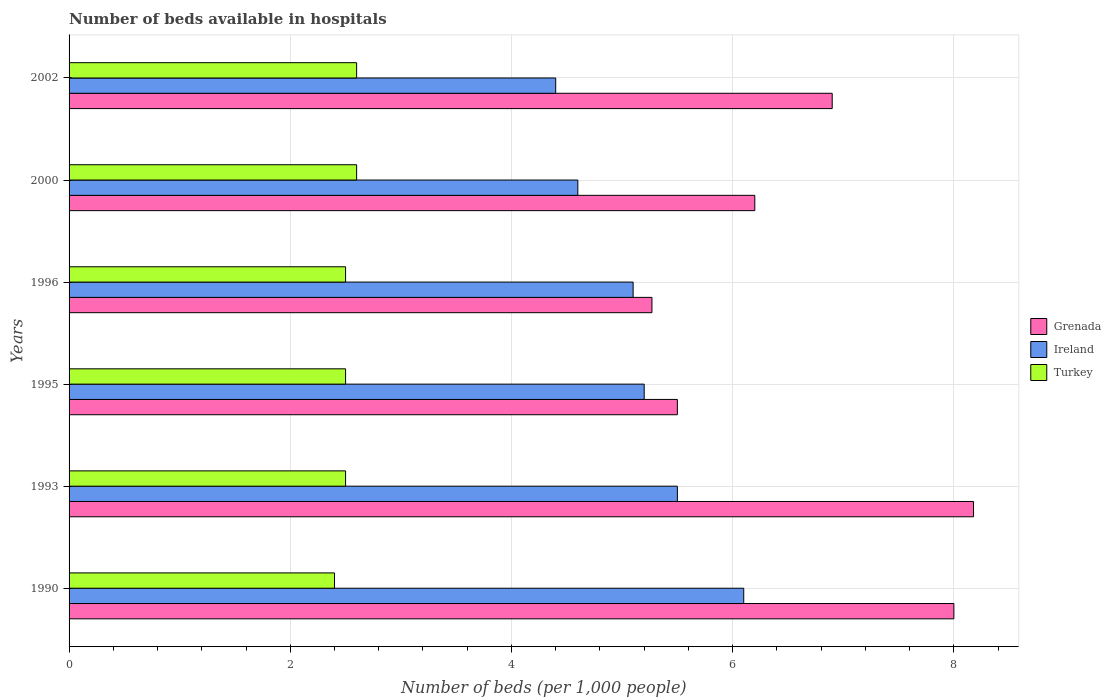How many different coloured bars are there?
Ensure brevity in your answer.  3. Are the number of bars on each tick of the Y-axis equal?
Offer a very short reply. Yes. How many bars are there on the 5th tick from the bottom?
Your answer should be very brief. 3. What is the number of beds in the hospiatls of in Turkey in 2002?
Your answer should be very brief. 2.6. Across all years, what is the maximum number of beds in the hospiatls of in Turkey?
Your response must be concise. 2.6. Across all years, what is the minimum number of beds in the hospiatls of in Ireland?
Provide a succinct answer. 4.4. In which year was the number of beds in the hospiatls of in Grenada maximum?
Provide a short and direct response. 1993. In which year was the number of beds in the hospiatls of in Ireland minimum?
Your answer should be very brief. 2002. What is the total number of beds in the hospiatls of in Grenada in the graph?
Offer a terse response. 40.05. What is the difference between the number of beds in the hospiatls of in Turkey in 1990 and that in 1996?
Your answer should be very brief. -0.1. What is the difference between the number of beds in the hospiatls of in Turkey in 1990 and the number of beds in the hospiatls of in Grenada in 2002?
Keep it short and to the point. -4.5. What is the average number of beds in the hospiatls of in Grenada per year?
Make the answer very short. 6.67. In the year 2002, what is the difference between the number of beds in the hospiatls of in Grenada and number of beds in the hospiatls of in Turkey?
Give a very brief answer. 4.3. In how many years, is the number of beds in the hospiatls of in Grenada greater than 7.6 ?
Provide a short and direct response. 2. What is the ratio of the number of beds in the hospiatls of in Ireland in 1993 to that in 2000?
Make the answer very short. 1.2. Is the number of beds in the hospiatls of in Turkey in 1996 less than that in 2000?
Offer a terse response. Yes. What is the difference between the highest and the second highest number of beds in the hospiatls of in Grenada?
Give a very brief answer. 0.18. What is the difference between the highest and the lowest number of beds in the hospiatls of in Grenada?
Offer a very short reply. 2.91. In how many years, is the number of beds in the hospiatls of in Turkey greater than the average number of beds in the hospiatls of in Turkey taken over all years?
Your answer should be very brief. 2. Is the sum of the number of beds in the hospiatls of in Grenada in 1990 and 1996 greater than the maximum number of beds in the hospiatls of in Turkey across all years?
Provide a succinct answer. Yes. What does the 1st bar from the bottom in 1990 represents?
Offer a very short reply. Grenada. How many bars are there?
Keep it short and to the point. 18. Are all the bars in the graph horizontal?
Make the answer very short. Yes. How many years are there in the graph?
Your answer should be very brief. 6. What is the difference between two consecutive major ticks on the X-axis?
Offer a terse response. 2. Does the graph contain any zero values?
Keep it short and to the point. No. Does the graph contain grids?
Your response must be concise. Yes. Where does the legend appear in the graph?
Keep it short and to the point. Center right. How many legend labels are there?
Make the answer very short. 3. What is the title of the graph?
Provide a succinct answer. Number of beds available in hospitals. Does "Congo (Democratic)" appear as one of the legend labels in the graph?
Give a very brief answer. No. What is the label or title of the X-axis?
Keep it short and to the point. Number of beds (per 1,0 people). What is the Number of beds (per 1,000 people) of Ireland in 1990?
Offer a terse response. 6.1. What is the Number of beds (per 1,000 people) in Turkey in 1990?
Offer a very short reply. 2.4. What is the Number of beds (per 1,000 people) in Grenada in 1993?
Your answer should be compact. 8.18. What is the Number of beds (per 1,000 people) in Ireland in 1993?
Your response must be concise. 5.5. What is the Number of beds (per 1,000 people) in Grenada in 1995?
Your answer should be very brief. 5.5. What is the Number of beds (per 1,000 people) of Ireland in 1995?
Give a very brief answer. 5.2. What is the Number of beds (per 1,000 people) in Turkey in 1995?
Provide a succinct answer. 2.5. What is the Number of beds (per 1,000 people) of Grenada in 1996?
Give a very brief answer. 5.27. What is the Number of beds (per 1,000 people) in Ireland in 1996?
Your answer should be compact. 5.1. What is the Number of beds (per 1,000 people) of Grenada in 2000?
Ensure brevity in your answer.  6.2. What is the Number of beds (per 1,000 people) of Ireland in 2000?
Make the answer very short. 4.6. What is the Number of beds (per 1,000 people) of Turkey in 2000?
Your response must be concise. 2.6. What is the Number of beds (per 1,000 people) of Grenada in 2002?
Give a very brief answer. 6.9. What is the Number of beds (per 1,000 people) of Ireland in 2002?
Keep it short and to the point. 4.4. What is the Number of beds (per 1,000 people) of Turkey in 2002?
Offer a terse response. 2.6. Across all years, what is the maximum Number of beds (per 1,000 people) in Grenada?
Make the answer very short. 8.18. Across all years, what is the maximum Number of beds (per 1,000 people) of Ireland?
Keep it short and to the point. 6.1. Across all years, what is the maximum Number of beds (per 1,000 people) in Turkey?
Ensure brevity in your answer.  2.6. Across all years, what is the minimum Number of beds (per 1,000 people) of Grenada?
Offer a very short reply. 5.27. Across all years, what is the minimum Number of beds (per 1,000 people) in Ireland?
Provide a succinct answer. 4.4. Across all years, what is the minimum Number of beds (per 1,000 people) of Turkey?
Offer a very short reply. 2.4. What is the total Number of beds (per 1,000 people) of Grenada in the graph?
Your response must be concise. 40.05. What is the total Number of beds (per 1,000 people) of Ireland in the graph?
Your answer should be compact. 30.9. What is the total Number of beds (per 1,000 people) in Turkey in the graph?
Your answer should be very brief. 15.1. What is the difference between the Number of beds (per 1,000 people) in Grenada in 1990 and that in 1993?
Ensure brevity in your answer.  -0.18. What is the difference between the Number of beds (per 1,000 people) in Ireland in 1990 and that in 1993?
Offer a terse response. 0.6. What is the difference between the Number of beds (per 1,000 people) in Turkey in 1990 and that in 1993?
Offer a very short reply. -0.1. What is the difference between the Number of beds (per 1,000 people) of Grenada in 1990 and that in 1995?
Offer a very short reply. 2.5. What is the difference between the Number of beds (per 1,000 people) of Grenada in 1990 and that in 1996?
Your answer should be very brief. 2.73. What is the difference between the Number of beds (per 1,000 people) of Ireland in 1990 and that in 1996?
Make the answer very short. 1. What is the difference between the Number of beds (per 1,000 people) of Turkey in 1990 and that in 1996?
Your response must be concise. -0.1. What is the difference between the Number of beds (per 1,000 people) of Grenada in 1990 and that in 2000?
Keep it short and to the point. 1.8. What is the difference between the Number of beds (per 1,000 people) in Ireland in 1990 and that in 2000?
Make the answer very short. 1.5. What is the difference between the Number of beds (per 1,000 people) in Grenada in 1993 and that in 1995?
Offer a very short reply. 2.68. What is the difference between the Number of beds (per 1,000 people) in Turkey in 1993 and that in 1995?
Your response must be concise. 0. What is the difference between the Number of beds (per 1,000 people) in Grenada in 1993 and that in 1996?
Offer a very short reply. 2.91. What is the difference between the Number of beds (per 1,000 people) of Turkey in 1993 and that in 1996?
Offer a very short reply. 0. What is the difference between the Number of beds (per 1,000 people) of Grenada in 1993 and that in 2000?
Your answer should be compact. 1.98. What is the difference between the Number of beds (per 1,000 people) of Ireland in 1993 and that in 2000?
Make the answer very short. 0.9. What is the difference between the Number of beds (per 1,000 people) in Turkey in 1993 and that in 2000?
Your response must be concise. -0.1. What is the difference between the Number of beds (per 1,000 people) in Grenada in 1993 and that in 2002?
Offer a terse response. 1.28. What is the difference between the Number of beds (per 1,000 people) of Turkey in 1993 and that in 2002?
Your answer should be very brief. -0.1. What is the difference between the Number of beds (per 1,000 people) of Grenada in 1995 and that in 1996?
Keep it short and to the point. 0.23. What is the difference between the Number of beds (per 1,000 people) in Ireland in 1995 and that in 1996?
Make the answer very short. 0.1. What is the difference between the Number of beds (per 1,000 people) in Turkey in 1995 and that in 2000?
Your answer should be compact. -0.1. What is the difference between the Number of beds (per 1,000 people) of Grenada in 1995 and that in 2002?
Your response must be concise. -1.4. What is the difference between the Number of beds (per 1,000 people) of Ireland in 1995 and that in 2002?
Keep it short and to the point. 0.8. What is the difference between the Number of beds (per 1,000 people) in Grenada in 1996 and that in 2000?
Your answer should be very brief. -0.93. What is the difference between the Number of beds (per 1,000 people) in Turkey in 1996 and that in 2000?
Offer a terse response. -0.1. What is the difference between the Number of beds (per 1,000 people) in Grenada in 1996 and that in 2002?
Offer a very short reply. -1.63. What is the difference between the Number of beds (per 1,000 people) of Turkey in 1996 and that in 2002?
Your answer should be compact. -0.1. What is the difference between the Number of beds (per 1,000 people) in Grenada in 2000 and that in 2002?
Offer a very short reply. -0.7. What is the difference between the Number of beds (per 1,000 people) of Grenada in 1990 and the Number of beds (per 1,000 people) of Ireland in 1993?
Provide a succinct answer. 2.5. What is the difference between the Number of beds (per 1,000 people) in Grenada in 1990 and the Number of beds (per 1,000 people) in Turkey in 1993?
Give a very brief answer. 5.5. What is the difference between the Number of beds (per 1,000 people) in Grenada in 1990 and the Number of beds (per 1,000 people) in Turkey in 1995?
Provide a succinct answer. 5.5. What is the difference between the Number of beds (per 1,000 people) in Grenada in 1990 and the Number of beds (per 1,000 people) in Turkey in 2000?
Your response must be concise. 5.4. What is the difference between the Number of beds (per 1,000 people) in Grenada in 1990 and the Number of beds (per 1,000 people) in Ireland in 2002?
Your answer should be very brief. 3.6. What is the difference between the Number of beds (per 1,000 people) of Grenada in 1993 and the Number of beds (per 1,000 people) of Ireland in 1995?
Keep it short and to the point. 2.98. What is the difference between the Number of beds (per 1,000 people) of Grenada in 1993 and the Number of beds (per 1,000 people) of Turkey in 1995?
Provide a succinct answer. 5.68. What is the difference between the Number of beds (per 1,000 people) in Ireland in 1993 and the Number of beds (per 1,000 people) in Turkey in 1995?
Make the answer very short. 3. What is the difference between the Number of beds (per 1,000 people) in Grenada in 1993 and the Number of beds (per 1,000 people) in Ireland in 1996?
Offer a terse response. 3.08. What is the difference between the Number of beds (per 1,000 people) in Grenada in 1993 and the Number of beds (per 1,000 people) in Turkey in 1996?
Make the answer very short. 5.68. What is the difference between the Number of beds (per 1,000 people) of Grenada in 1993 and the Number of beds (per 1,000 people) of Ireland in 2000?
Keep it short and to the point. 3.58. What is the difference between the Number of beds (per 1,000 people) of Grenada in 1993 and the Number of beds (per 1,000 people) of Turkey in 2000?
Your answer should be compact. 5.58. What is the difference between the Number of beds (per 1,000 people) of Grenada in 1993 and the Number of beds (per 1,000 people) of Ireland in 2002?
Your answer should be very brief. 3.78. What is the difference between the Number of beds (per 1,000 people) in Grenada in 1993 and the Number of beds (per 1,000 people) in Turkey in 2002?
Offer a terse response. 5.58. What is the difference between the Number of beds (per 1,000 people) of Grenada in 1995 and the Number of beds (per 1,000 people) of Ireland in 1996?
Your answer should be compact. 0.4. What is the difference between the Number of beds (per 1,000 people) in Ireland in 1995 and the Number of beds (per 1,000 people) in Turkey in 1996?
Offer a very short reply. 2.7. What is the difference between the Number of beds (per 1,000 people) in Grenada in 1995 and the Number of beds (per 1,000 people) in Turkey in 2002?
Give a very brief answer. 2.9. What is the difference between the Number of beds (per 1,000 people) in Ireland in 1995 and the Number of beds (per 1,000 people) in Turkey in 2002?
Offer a terse response. 2.6. What is the difference between the Number of beds (per 1,000 people) of Grenada in 1996 and the Number of beds (per 1,000 people) of Ireland in 2000?
Give a very brief answer. 0.67. What is the difference between the Number of beds (per 1,000 people) of Grenada in 1996 and the Number of beds (per 1,000 people) of Turkey in 2000?
Offer a very short reply. 2.67. What is the difference between the Number of beds (per 1,000 people) in Ireland in 1996 and the Number of beds (per 1,000 people) in Turkey in 2000?
Provide a short and direct response. 2.5. What is the difference between the Number of beds (per 1,000 people) in Grenada in 1996 and the Number of beds (per 1,000 people) in Ireland in 2002?
Give a very brief answer. 0.87. What is the difference between the Number of beds (per 1,000 people) in Grenada in 1996 and the Number of beds (per 1,000 people) in Turkey in 2002?
Offer a terse response. 2.67. What is the difference between the Number of beds (per 1,000 people) of Ireland in 1996 and the Number of beds (per 1,000 people) of Turkey in 2002?
Make the answer very short. 2.5. What is the difference between the Number of beds (per 1,000 people) in Grenada in 2000 and the Number of beds (per 1,000 people) in Ireland in 2002?
Ensure brevity in your answer.  1.8. What is the difference between the Number of beds (per 1,000 people) of Grenada in 2000 and the Number of beds (per 1,000 people) of Turkey in 2002?
Your answer should be compact. 3.6. What is the difference between the Number of beds (per 1,000 people) of Ireland in 2000 and the Number of beds (per 1,000 people) of Turkey in 2002?
Provide a succinct answer. 2. What is the average Number of beds (per 1,000 people) of Grenada per year?
Your response must be concise. 6.67. What is the average Number of beds (per 1,000 people) of Ireland per year?
Your answer should be very brief. 5.15. What is the average Number of beds (per 1,000 people) of Turkey per year?
Provide a succinct answer. 2.52. In the year 1990, what is the difference between the Number of beds (per 1,000 people) of Grenada and Number of beds (per 1,000 people) of Ireland?
Give a very brief answer. 1.9. In the year 1990, what is the difference between the Number of beds (per 1,000 people) in Grenada and Number of beds (per 1,000 people) in Turkey?
Give a very brief answer. 5.6. In the year 1990, what is the difference between the Number of beds (per 1,000 people) of Ireland and Number of beds (per 1,000 people) of Turkey?
Provide a succinct answer. 3.7. In the year 1993, what is the difference between the Number of beds (per 1,000 people) in Grenada and Number of beds (per 1,000 people) in Ireland?
Your answer should be very brief. 2.68. In the year 1993, what is the difference between the Number of beds (per 1,000 people) of Grenada and Number of beds (per 1,000 people) of Turkey?
Provide a short and direct response. 5.68. In the year 1995, what is the difference between the Number of beds (per 1,000 people) of Grenada and Number of beds (per 1,000 people) of Ireland?
Your answer should be very brief. 0.3. In the year 1996, what is the difference between the Number of beds (per 1,000 people) in Grenada and Number of beds (per 1,000 people) in Ireland?
Make the answer very short. 0.17. In the year 1996, what is the difference between the Number of beds (per 1,000 people) of Grenada and Number of beds (per 1,000 people) of Turkey?
Make the answer very short. 2.77. In the year 1996, what is the difference between the Number of beds (per 1,000 people) in Ireland and Number of beds (per 1,000 people) in Turkey?
Keep it short and to the point. 2.6. In the year 2000, what is the difference between the Number of beds (per 1,000 people) of Ireland and Number of beds (per 1,000 people) of Turkey?
Provide a succinct answer. 2. In the year 2002, what is the difference between the Number of beds (per 1,000 people) of Grenada and Number of beds (per 1,000 people) of Turkey?
Your response must be concise. 4.3. What is the ratio of the Number of beds (per 1,000 people) of Grenada in 1990 to that in 1993?
Provide a succinct answer. 0.98. What is the ratio of the Number of beds (per 1,000 people) in Ireland in 1990 to that in 1993?
Make the answer very short. 1.11. What is the ratio of the Number of beds (per 1,000 people) of Turkey in 1990 to that in 1993?
Your response must be concise. 0.96. What is the ratio of the Number of beds (per 1,000 people) of Grenada in 1990 to that in 1995?
Your response must be concise. 1.45. What is the ratio of the Number of beds (per 1,000 people) of Ireland in 1990 to that in 1995?
Offer a very short reply. 1.17. What is the ratio of the Number of beds (per 1,000 people) in Turkey in 1990 to that in 1995?
Provide a short and direct response. 0.96. What is the ratio of the Number of beds (per 1,000 people) of Grenada in 1990 to that in 1996?
Ensure brevity in your answer.  1.52. What is the ratio of the Number of beds (per 1,000 people) of Ireland in 1990 to that in 1996?
Offer a very short reply. 1.2. What is the ratio of the Number of beds (per 1,000 people) in Grenada in 1990 to that in 2000?
Provide a succinct answer. 1.29. What is the ratio of the Number of beds (per 1,000 people) of Ireland in 1990 to that in 2000?
Your answer should be very brief. 1.33. What is the ratio of the Number of beds (per 1,000 people) in Turkey in 1990 to that in 2000?
Provide a short and direct response. 0.92. What is the ratio of the Number of beds (per 1,000 people) in Grenada in 1990 to that in 2002?
Give a very brief answer. 1.16. What is the ratio of the Number of beds (per 1,000 people) of Ireland in 1990 to that in 2002?
Provide a short and direct response. 1.39. What is the ratio of the Number of beds (per 1,000 people) of Turkey in 1990 to that in 2002?
Your response must be concise. 0.92. What is the ratio of the Number of beds (per 1,000 people) of Grenada in 1993 to that in 1995?
Provide a succinct answer. 1.49. What is the ratio of the Number of beds (per 1,000 people) of Ireland in 1993 to that in 1995?
Offer a very short reply. 1.06. What is the ratio of the Number of beds (per 1,000 people) in Turkey in 1993 to that in 1995?
Your response must be concise. 1. What is the ratio of the Number of beds (per 1,000 people) of Grenada in 1993 to that in 1996?
Ensure brevity in your answer.  1.55. What is the ratio of the Number of beds (per 1,000 people) of Ireland in 1993 to that in 1996?
Your response must be concise. 1.08. What is the ratio of the Number of beds (per 1,000 people) of Turkey in 1993 to that in 1996?
Your answer should be very brief. 1. What is the ratio of the Number of beds (per 1,000 people) in Grenada in 1993 to that in 2000?
Keep it short and to the point. 1.32. What is the ratio of the Number of beds (per 1,000 people) of Ireland in 1993 to that in 2000?
Offer a very short reply. 1.2. What is the ratio of the Number of beds (per 1,000 people) of Turkey in 1993 to that in 2000?
Your answer should be compact. 0.96. What is the ratio of the Number of beds (per 1,000 people) of Grenada in 1993 to that in 2002?
Offer a very short reply. 1.19. What is the ratio of the Number of beds (per 1,000 people) in Turkey in 1993 to that in 2002?
Provide a short and direct response. 0.96. What is the ratio of the Number of beds (per 1,000 people) in Grenada in 1995 to that in 1996?
Provide a succinct answer. 1.04. What is the ratio of the Number of beds (per 1,000 people) in Ireland in 1995 to that in 1996?
Give a very brief answer. 1.02. What is the ratio of the Number of beds (per 1,000 people) of Grenada in 1995 to that in 2000?
Offer a terse response. 0.89. What is the ratio of the Number of beds (per 1,000 people) in Ireland in 1995 to that in 2000?
Ensure brevity in your answer.  1.13. What is the ratio of the Number of beds (per 1,000 people) in Turkey in 1995 to that in 2000?
Provide a succinct answer. 0.96. What is the ratio of the Number of beds (per 1,000 people) of Grenada in 1995 to that in 2002?
Your response must be concise. 0.8. What is the ratio of the Number of beds (per 1,000 people) in Ireland in 1995 to that in 2002?
Give a very brief answer. 1.18. What is the ratio of the Number of beds (per 1,000 people) of Turkey in 1995 to that in 2002?
Your answer should be very brief. 0.96. What is the ratio of the Number of beds (per 1,000 people) in Ireland in 1996 to that in 2000?
Offer a very short reply. 1.11. What is the ratio of the Number of beds (per 1,000 people) of Turkey in 1996 to that in 2000?
Your answer should be very brief. 0.96. What is the ratio of the Number of beds (per 1,000 people) in Grenada in 1996 to that in 2002?
Your answer should be very brief. 0.76. What is the ratio of the Number of beds (per 1,000 people) of Ireland in 1996 to that in 2002?
Offer a very short reply. 1.16. What is the ratio of the Number of beds (per 1,000 people) of Turkey in 1996 to that in 2002?
Provide a succinct answer. 0.96. What is the ratio of the Number of beds (per 1,000 people) of Grenada in 2000 to that in 2002?
Provide a succinct answer. 0.9. What is the ratio of the Number of beds (per 1,000 people) of Ireland in 2000 to that in 2002?
Give a very brief answer. 1.05. What is the ratio of the Number of beds (per 1,000 people) in Turkey in 2000 to that in 2002?
Your response must be concise. 1. What is the difference between the highest and the second highest Number of beds (per 1,000 people) of Grenada?
Make the answer very short. 0.18. What is the difference between the highest and the second highest Number of beds (per 1,000 people) in Turkey?
Provide a short and direct response. 0. What is the difference between the highest and the lowest Number of beds (per 1,000 people) of Grenada?
Give a very brief answer. 2.91. What is the difference between the highest and the lowest Number of beds (per 1,000 people) of Ireland?
Offer a very short reply. 1.7. 